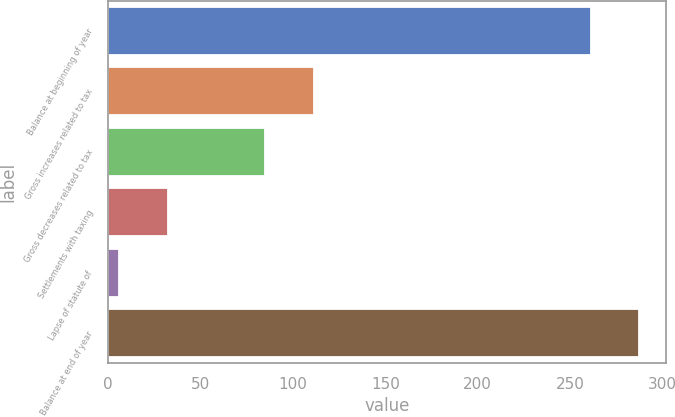<chart> <loc_0><loc_0><loc_500><loc_500><bar_chart><fcel>Balance at beginning of year<fcel>Gross increases related to tax<fcel>Gross decreases related to tax<fcel>Settlements with taxing<fcel>Lapse of statute of<fcel>Balance at end of year<nl><fcel>261<fcel>111.2<fcel>84.9<fcel>32.3<fcel>6<fcel>287.3<nl></chart> 